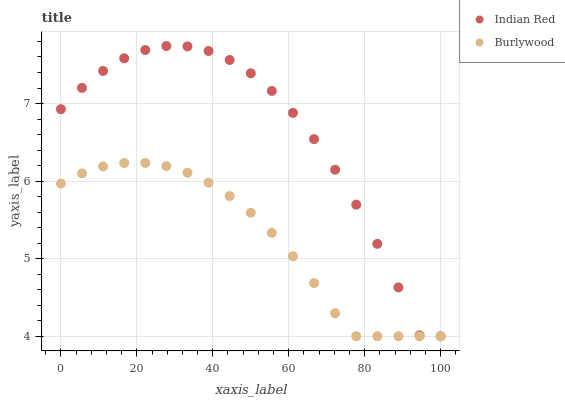Does Burlywood have the minimum area under the curve?
Answer yes or no. Yes. Does Indian Red have the maximum area under the curve?
Answer yes or no. Yes. Does Indian Red have the minimum area under the curve?
Answer yes or no. No. Is Burlywood the smoothest?
Answer yes or no. Yes. Is Indian Red the roughest?
Answer yes or no. Yes. Is Indian Red the smoothest?
Answer yes or no. No. Does Burlywood have the lowest value?
Answer yes or no. Yes. Does Indian Red have the highest value?
Answer yes or no. Yes. Does Indian Red intersect Burlywood?
Answer yes or no. Yes. Is Indian Red less than Burlywood?
Answer yes or no. No. Is Indian Red greater than Burlywood?
Answer yes or no. No. 